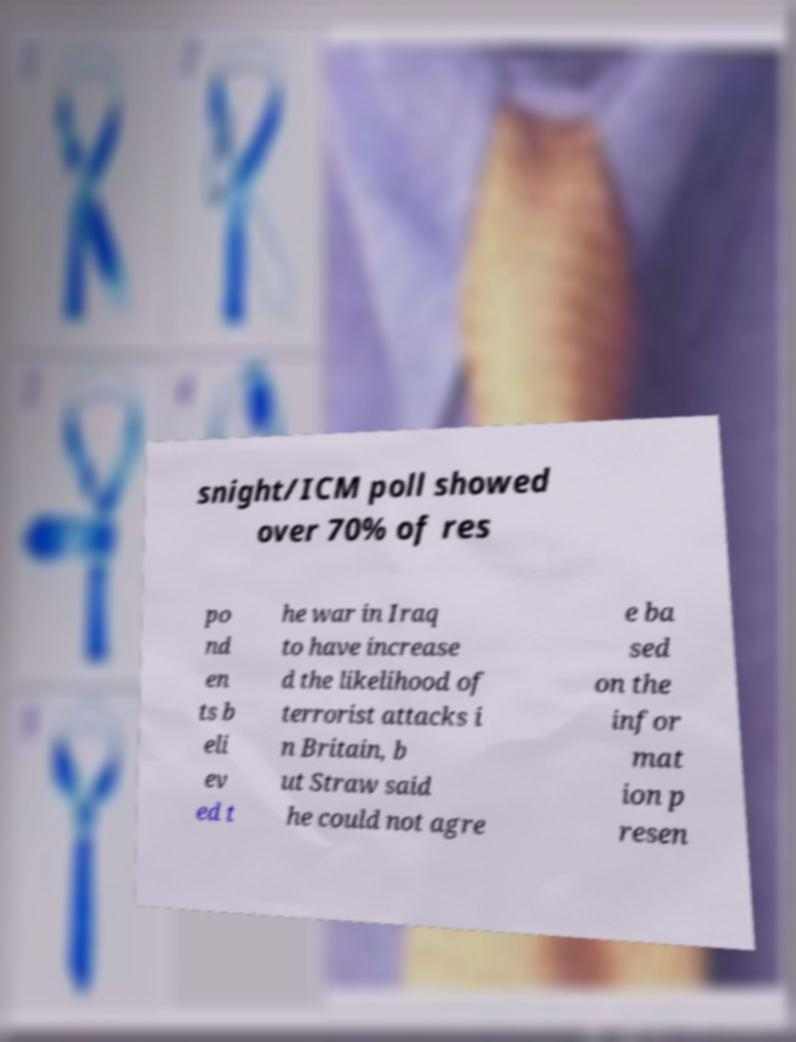Please identify and transcribe the text found in this image. snight/ICM poll showed over 70% of res po nd en ts b eli ev ed t he war in Iraq to have increase d the likelihood of terrorist attacks i n Britain, b ut Straw said he could not agre e ba sed on the infor mat ion p resen 